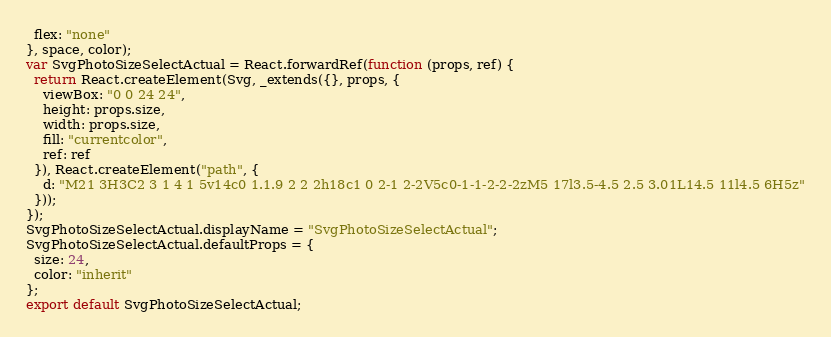Convert code to text. <code><loc_0><loc_0><loc_500><loc_500><_JavaScript_>  flex: "none"
}, space, color);
var SvgPhotoSizeSelectActual = React.forwardRef(function (props, ref) {
  return React.createElement(Svg, _extends({}, props, {
    viewBox: "0 0 24 24",
    height: props.size,
    width: props.size,
    fill: "currentcolor",
    ref: ref
  }), React.createElement("path", {
    d: "M21 3H3C2 3 1 4 1 5v14c0 1.1.9 2 2 2h18c1 0 2-1 2-2V5c0-1-1-2-2-2zM5 17l3.5-4.5 2.5 3.01L14.5 11l4.5 6H5z"
  }));
});
SvgPhotoSizeSelectActual.displayName = "SvgPhotoSizeSelectActual";
SvgPhotoSizeSelectActual.defaultProps = {
  size: 24,
  color: "inherit"
};
export default SvgPhotoSizeSelectActual;</code> 